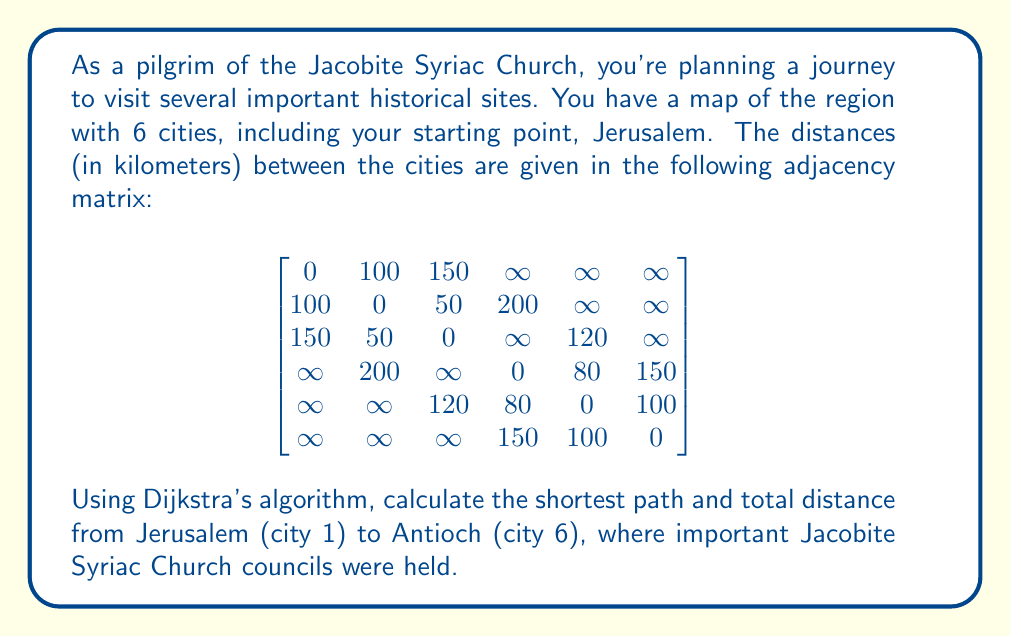Can you solve this math problem? To solve this problem, we'll apply Dijkstra's algorithm to find the shortest path from Jerusalem (city 1) to Antioch (city 6). Let's go through the steps:

1) Initialize:
   - Distance to Jerusalem (1): 0
   - Distance to all other cities: $\infty$
   - Set of unvisited cities: {1, 2, 3, 4, 5, 6}

2) From Jerusalem (1):
   - Update distances: d(2) = 100, d(3) = 150
   - Select city 2 (shortest distance)
   - Unvisited: {1, 3, 4, 5, 6}

3) From city 2:
   - Update: d(3) = min(150, 100 + 50) = 150, d(4) = 300
   - Select city 3
   - Unvisited: {1, 4, 5, 6}

4) From city 3:
   - Update: d(5) = 270
   - Select city 5
   - Unvisited: {1, 4, 6}

5) From city 5:
   - Update: d(4) = min(300, 270 + 80) = 300, d(6) = 370
   - Select city 4
   - Unvisited: {1, 6}

6) From city 4:
   - Update: d(6) = min(370, 300 + 150) = 370
   - Select city 6 (Antioch)
   - Algorithm complete

The shortest path is Jerusalem (1) → City 2 → City 3 → City 5 → Antioch (6).
Answer: The shortest path from Jerusalem to Antioch is 1 → 2 → 3 → 5 → 6, with a total distance of 370 km. 